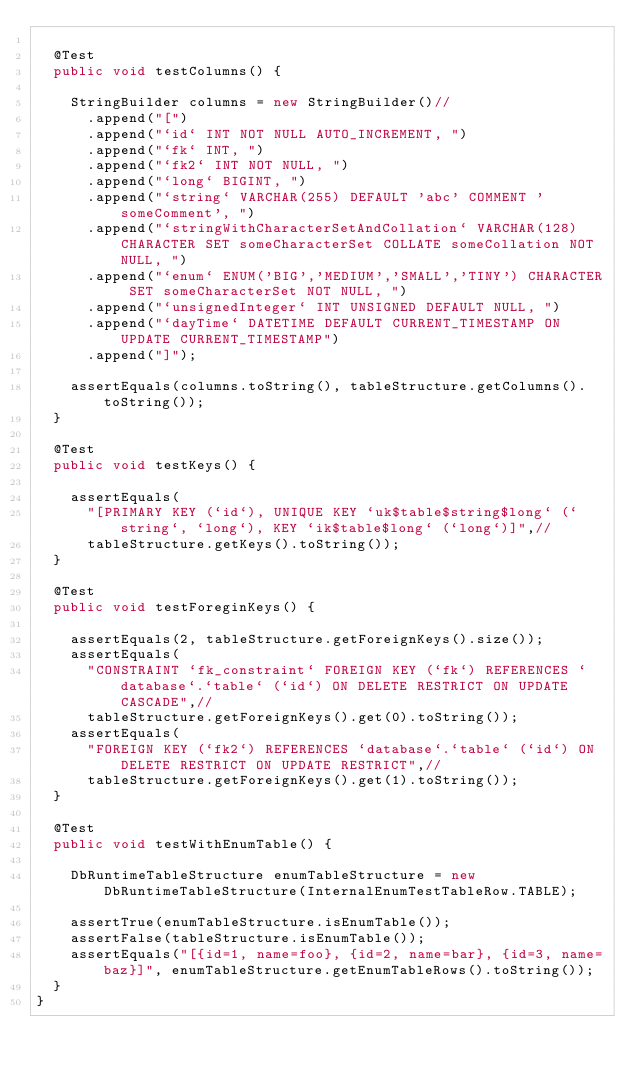<code> <loc_0><loc_0><loc_500><loc_500><_Java_>
	@Test
	public void testColumns() {

		StringBuilder columns = new StringBuilder()//
			.append("[")
			.append("`id` INT NOT NULL AUTO_INCREMENT, ")
			.append("`fk` INT, ")
			.append("`fk2` INT NOT NULL, ")
			.append("`long` BIGINT, ")
			.append("`string` VARCHAR(255) DEFAULT 'abc' COMMENT 'someComment', ")
			.append("`stringWithCharacterSetAndCollation` VARCHAR(128) CHARACTER SET someCharacterSet COLLATE someCollation NOT NULL, ")
			.append("`enum` ENUM('BIG','MEDIUM','SMALL','TINY') CHARACTER SET someCharacterSet NOT NULL, ")
			.append("`unsignedInteger` INT UNSIGNED DEFAULT NULL, ")
			.append("`dayTime` DATETIME DEFAULT CURRENT_TIMESTAMP ON UPDATE CURRENT_TIMESTAMP")
			.append("]");

		assertEquals(columns.toString(), tableStructure.getColumns().toString());
	}

	@Test
	public void testKeys() {

		assertEquals(
			"[PRIMARY KEY (`id`), UNIQUE KEY `uk$table$string$long` (`string`, `long`), KEY `ik$table$long` (`long`)]",//
			tableStructure.getKeys().toString());
	}

	@Test
	public void testForeginKeys() {

		assertEquals(2, tableStructure.getForeignKeys().size());
		assertEquals(
			"CONSTRAINT `fk_constraint` FOREIGN KEY (`fk`) REFERENCES `database`.`table` (`id`) ON DELETE RESTRICT ON UPDATE CASCADE",//
			tableStructure.getForeignKeys().get(0).toString());
		assertEquals(
			"FOREIGN KEY (`fk2`) REFERENCES `database`.`table` (`id`) ON DELETE RESTRICT ON UPDATE RESTRICT",//
			tableStructure.getForeignKeys().get(1).toString());
	}

	@Test
	public void testWithEnumTable() {

		DbRuntimeTableStructure enumTableStructure = new DbRuntimeTableStructure(InternalEnumTestTableRow.TABLE);

		assertTrue(enumTableStructure.isEnumTable());
		assertFalse(tableStructure.isEnumTable());
		assertEquals("[{id=1, name=foo}, {id=2, name=bar}, {id=3, name=baz}]", enumTableStructure.getEnumTableRows().toString());
	}
}
</code> 